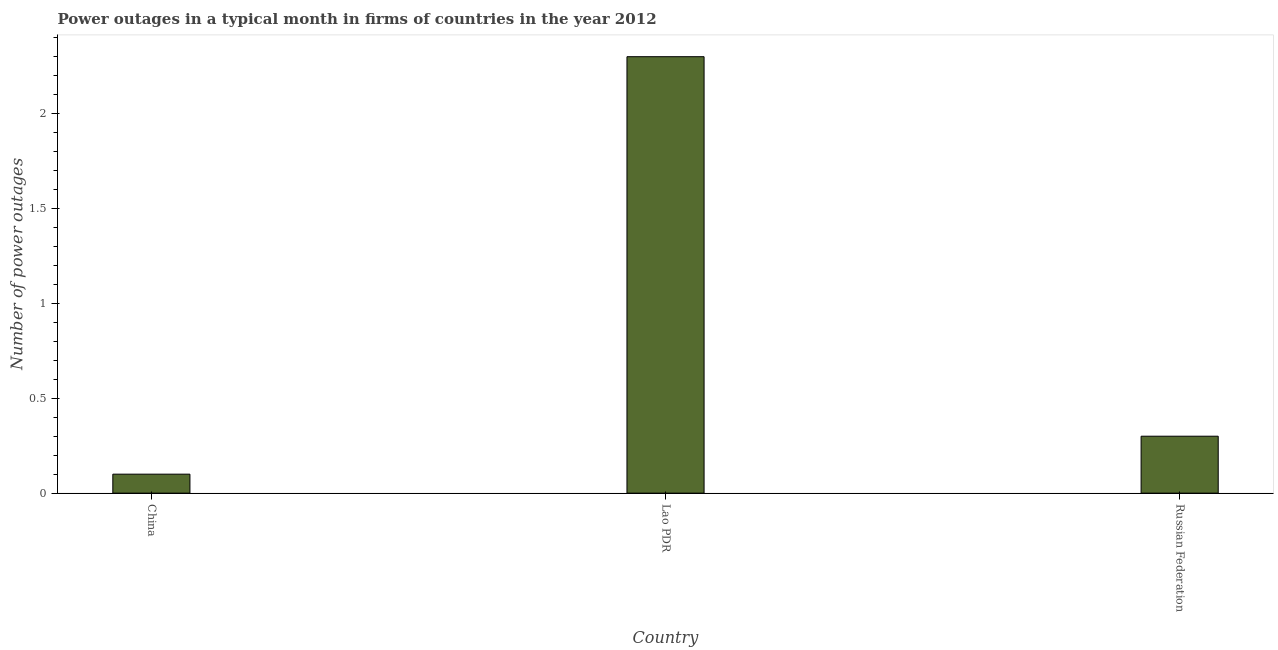Does the graph contain any zero values?
Offer a terse response. No. Does the graph contain grids?
Give a very brief answer. No. What is the title of the graph?
Offer a terse response. Power outages in a typical month in firms of countries in the year 2012. What is the label or title of the Y-axis?
Your answer should be compact. Number of power outages. Across all countries, what is the maximum number of power outages?
Offer a very short reply. 2.3. In which country was the number of power outages maximum?
Provide a succinct answer. Lao PDR. What is the sum of the number of power outages?
Make the answer very short. 2.7. In how many countries, is the number of power outages greater than 0.6 ?
Provide a short and direct response. 1. What is the ratio of the number of power outages in Lao PDR to that in Russian Federation?
Ensure brevity in your answer.  7.67. Is the difference between the number of power outages in China and Russian Federation greater than the difference between any two countries?
Provide a short and direct response. No. What is the difference between the highest and the second highest number of power outages?
Give a very brief answer. 2. What is the difference between the highest and the lowest number of power outages?
Provide a short and direct response. 2.2. How many bars are there?
Make the answer very short. 3. Are all the bars in the graph horizontal?
Your response must be concise. No. How many countries are there in the graph?
Make the answer very short. 3. Are the values on the major ticks of Y-axis written in scientific E-notation?
Your answer should be compact. No. What is the Number of power outages in China?
Provide a succinct answer. 0.1. What is the difference between the Number of power outages in China and Lao PDR?
Make the answer very short. -2.2. What is the difference between the Number of power outages in Lao PDR and Russian Federation?
Keep it short and to the point. 2. What is the ratio of the Number of power outages in China to that in Lao PDR?
Give a very brief answer. 0.04. What is the ratio of the Number of power outages in China to that in Russian Federation?
Provide a succinct answer. 0.33. What is the ratio of the Number of power outages in Lao PDR to that in Russian Federation?
Your answer should be compact. 7.67. 